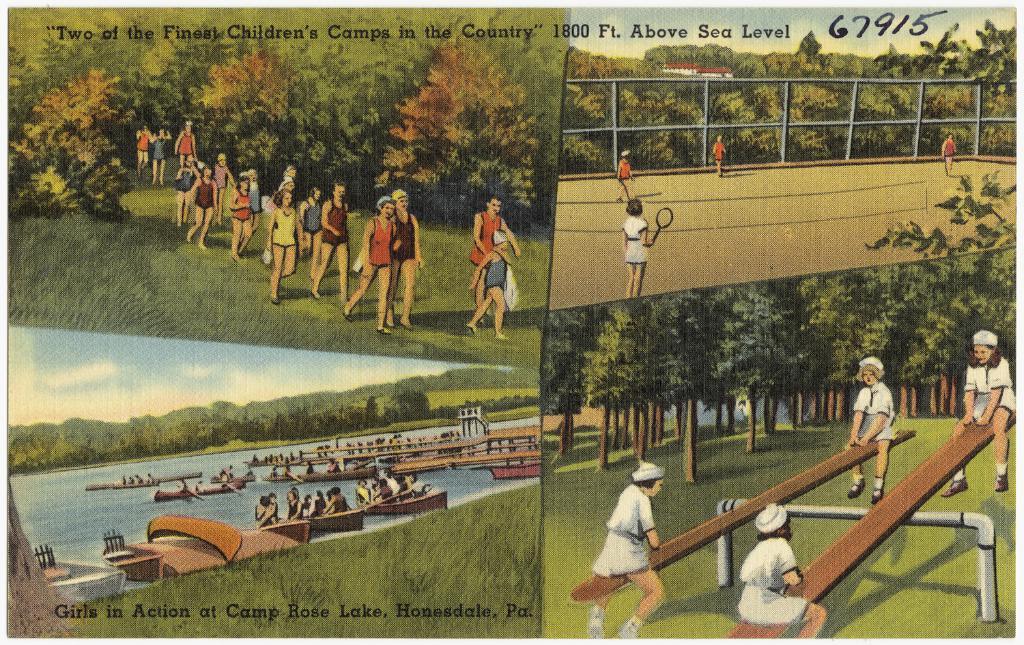What kind of camp is shown?
Offer a terse response. Children's. 